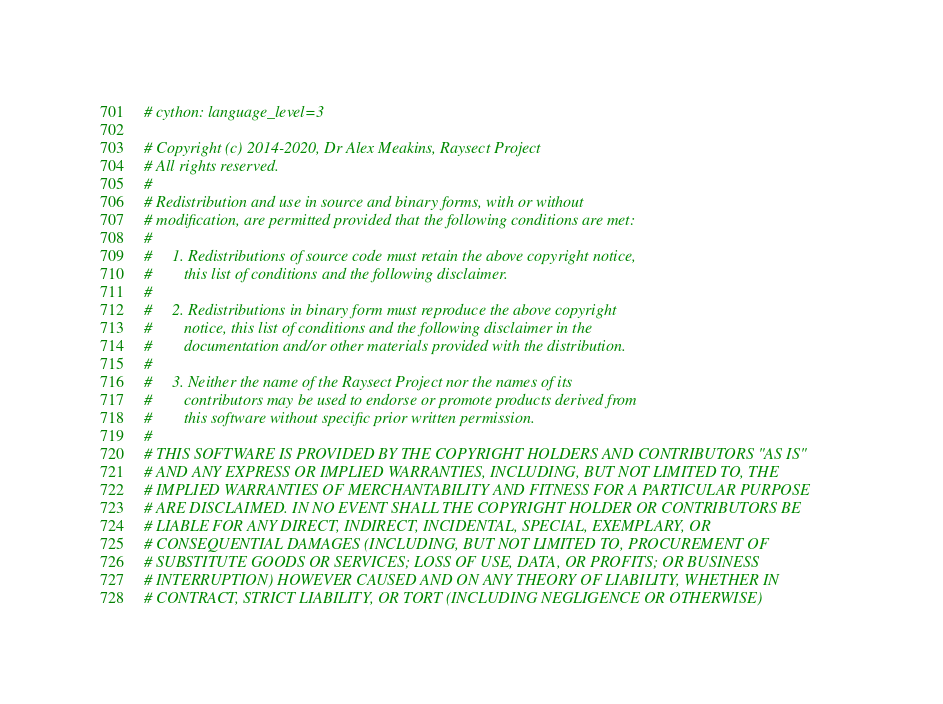Convert code to text. <code><loc_0><loc_0><loc_500><loc_500><_Cython_># cython: language_level=3

# Copyright (c) 2014-2020, Dr Alex Meakins, Raysect Project
# All rights reserved.
#
# Redistribution and use in source and binary forms, with or without
# modification, are permitted provided that the following conditions are met:
#
#     1. Redistributions of source code must retain the above copyright notice,
#        this list of conditions and the following disclaimer.
#
#     2. Redistributions in binary form must reproduce the above copyright
#        notice, this list of conditions and the following disclaimer in the
#        documentation and/or other materials provided with the distribution.
#
#     3. Neither the name of the Raysect Project nor the names of its
#        contributors may be used to endorse or promote products derived from
#        this software without specific prior written permission.
#
# THIS SOFTWARE IS PROVIDED BY THE COPYRIGHT HOLDERS AND CONTRIBUTORS "AS IS"
# AND ANY EXPRESS OR IMPLIED WARRANTIES, INCLUDING, BUT NOT LIMITED TO, THE
# IMPLIED WARRANTIES OF MERCHANTABILITY AND FITNESS FOR A PARTICULAR PURPOSE
# ARE DISCLAIMED. IN NO EVENT SHALL THE COPYRIGHT HOLDER OR CONTRIBUTORS BE
# LIABLE FOR ANY DIRECT, INDIRECT, INCIDENTAL, SPECIAL, EXEMPLARY, OR
# CONSEQUENTIAL DAMAGES (INCLUDING, BUT NOT LIMITED TO, PROCUREMENT OF
# SUBSTITUTE GOODS OR SERVICES; LOSS OF USE, DATA, OR PROFITS; OR BUSINESS
# INTERRUPTION) HOWEVER CAUSED AND ON ANY THEORY OF LIABILITY, WHETHER IN
# CONTRACT, STRICT LIABILITY, OR TORT (INCLUDING NEGLIGENCE OR OTHERWISE)</code> 